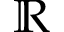Convert formula to latex. <formula><loc_0><loc_0><loc_500><loc_500>\mathbb { R }</formula> 